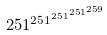Convert formula to latex. <formula><loc_0><loc_0><loc_500><loc_500>2 5 1 ^ { 2 5 1 ^ { 2 5 1 ^ { 2 5 1 ^ { 2 5 9 } } } }</formula> 